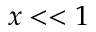Convert formula to latex. <formula><loc_0><loc_0><loc_500><loc_500>x < < 1</formula> 